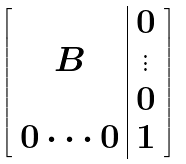<formula> <loc_0><loc_0><loc_500><loc_500>\left [ \begin{array} { c | c } & 0 \\ B & \vdots \\ & 0 \\ 0 \cdots 0 & 1 \end{array} \right ]</formula> 